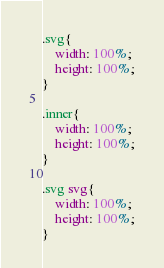<code> <loc_0><loc_0><loc_500><loc_500><_CSS_>

.svg{
    width: 100%;
    height: 100%;
}

.inner{
    width: 100%;
    height: 100%;
}

.svg svg{
    width: 100%;
    height: 100%;
}</code> 